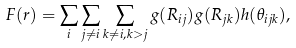Convert formula to latex. <formula><loc_0><loc_0><loc_500><loc_500>F ( r ) = \sum _ { i } \sum _ { j \neq i } \sum _ { k \neq i , k > j } g ( R _ { i j } ) g ( R _ { j k } ) h ( \theta _ { i j k } ) ,</formula> 